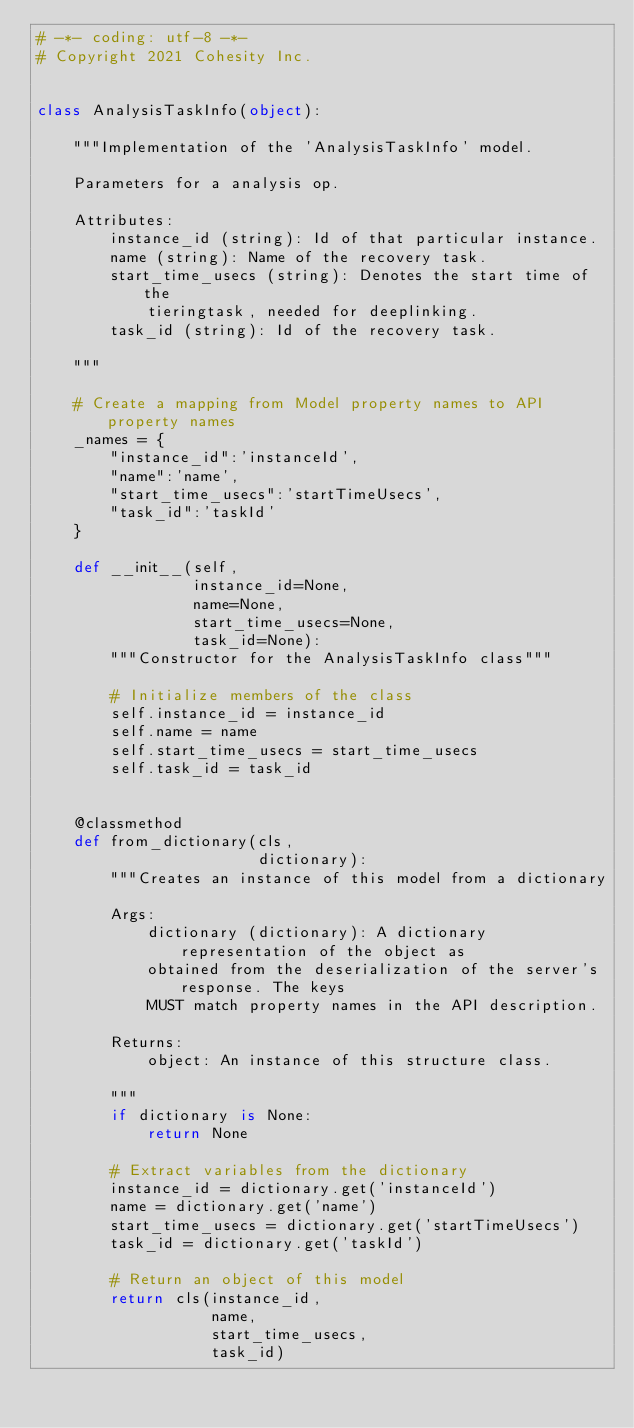Convert code to text. <code><loc_0><loc_0><loc_500><loc_500><_Python_># -*- coding: utf-8 -*-
# Copyright 2021 Cohesity Inc.


class AnalysisTaskInfo(object):

    """Implementation of the 'AnalysisTaskInfo' model.

    Parameters for a analysis op.

    Attributes:
        instance_id (string): Id of that particular instance.
        name (string): Name of the recovery task.
        start_time_usecs (string): Denotes the start time of the
            tieringtask, needed for deeplinking.
        task_id (string): Id of the recovery task.

    """

    # Create a mapping from Model property names to API property names
    _names = {
        "instance_id":'instanceId',
        "name":'name',
        "start_time_usecs":'startTimeUsecs',
        "task_id":'taskId'
    }

    def __init__(self,
                 instance_id=None,
                 name=None,
                 start_time_usecs=None,
                 task_id=None):
        """Constructor for the AnalysisTaskInfo class"""

        # Initialize members of the class
        self.instance_id = instance_id
        self.name = name
        self.start_time_usecs = start_time_usecs
        self.task_id = task_id


    @classmethod
    def from_dictionary(cls,
                        dictionary):
        """Creates an instance of this model from a dictionary

        Args:
            dictionary (dictionary): A dictionary representation of the object as
            obtained from the deserialization of the server's response. The keys
            MUST match property names in the API description.

        Returns:
            object: An instance of this structure class.

        """
        if dictionary is None:
            return None

        # Extract variables from the dictionary
        instance_id = dictionary.get('instanceId')
        name = dictionary.get('name')
        start_time_usecs = dictionary.get('startTimeUsecs')
        task_id = dictionary.get('taskId')

        # Return an object of this model
        return cls(instance_id,
                   name,
                   start_time_usecs,
                   task_id)


</code> 